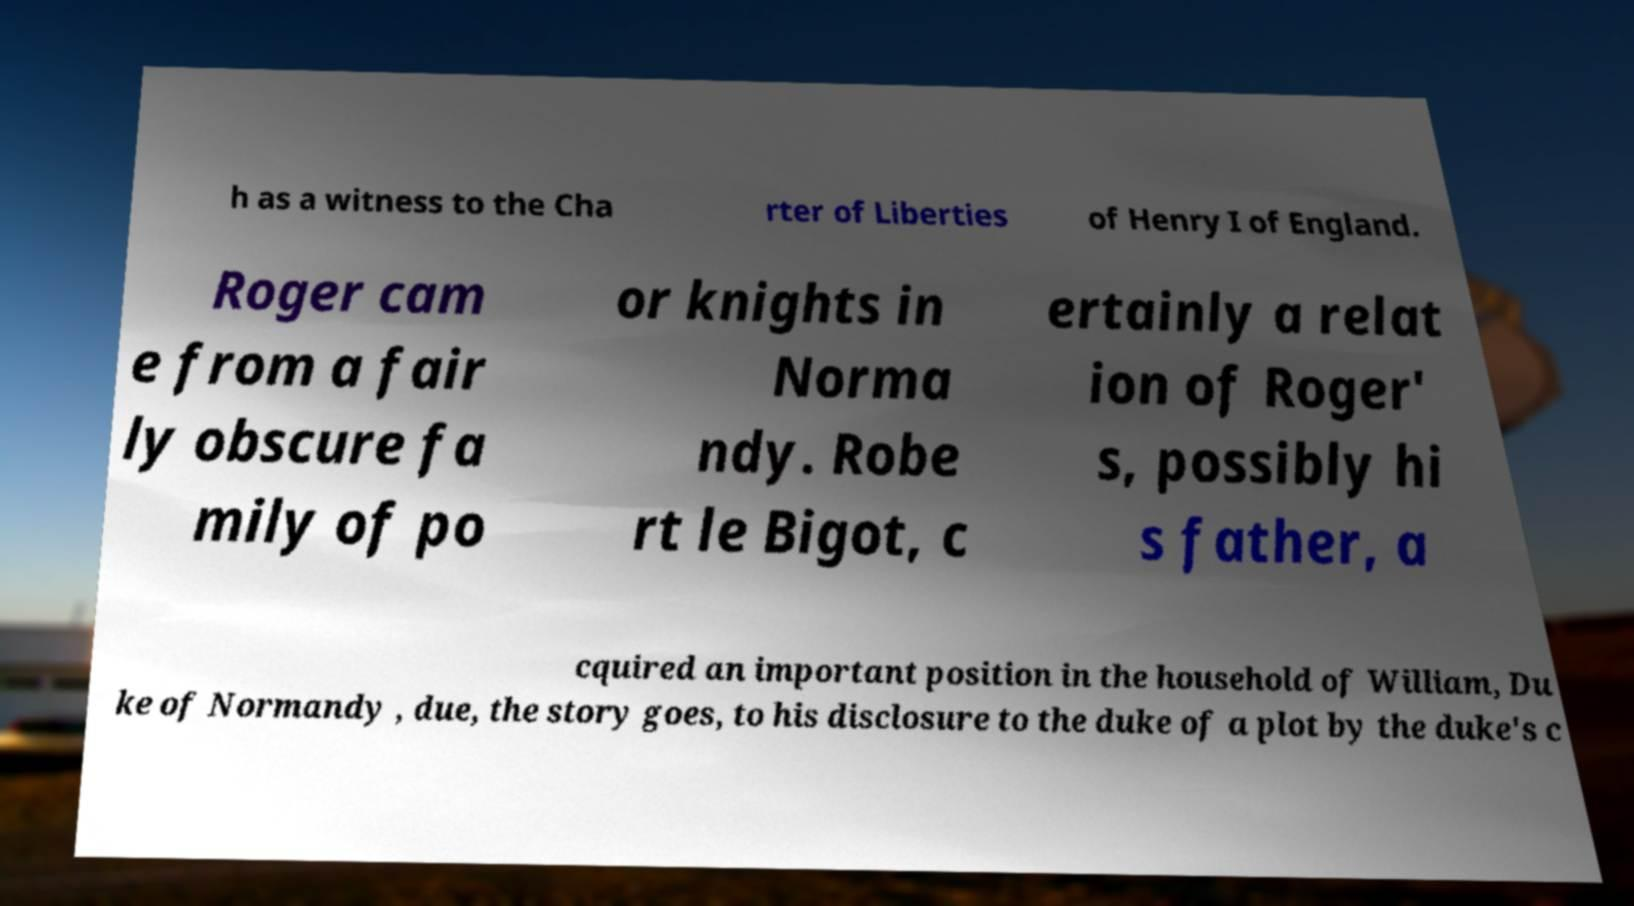I need the written content from this picture converted into text. Can you do that? h as a witness to the Cha rter of Liberties of Henry I of England. Roger cam e from a fair ly obscure fa mily of po or knights in Norma ndy. Robe rt le Bigot, c ertainly a relat ion of Roger' s, possibly hi s father, a cquired an important position in the household of William, Du ke of Normandy , due, the story goes, to his disclosure to the duke of a plot by the duke's c 